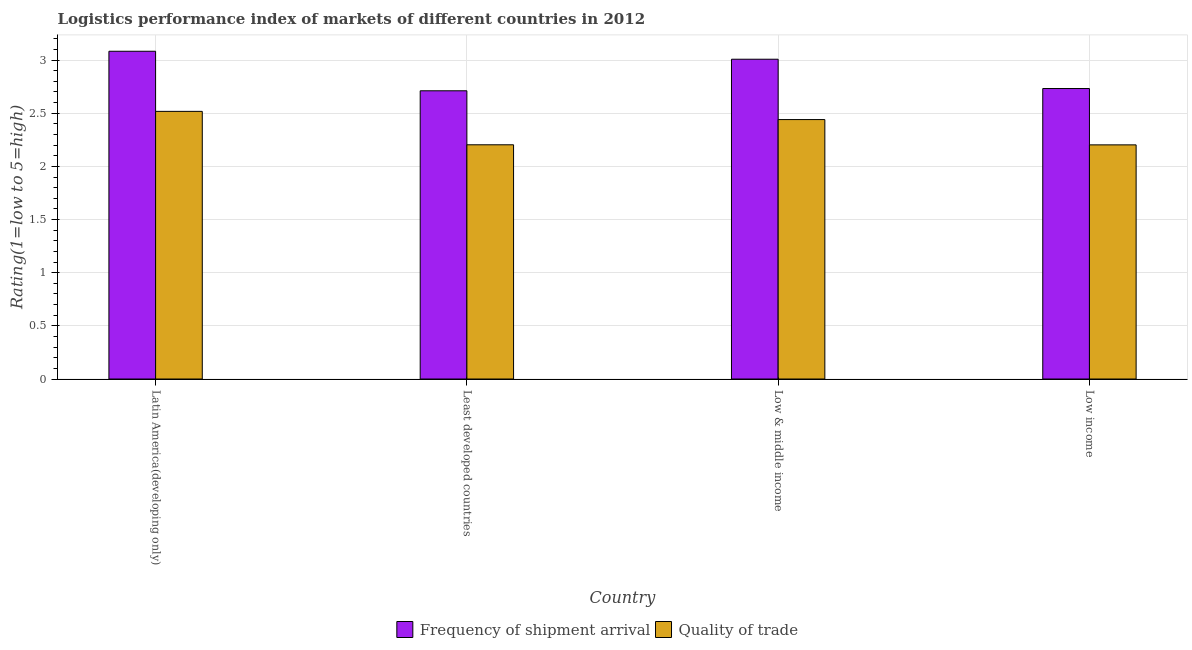How many different coloured bars are there?
Offer a terse response. 2. How many groups of bars are there?
Keep it short and to the point. 4. How many bars are there on the 4th tick from the right?
Keep it short and to the point. 2. What is the label of the 3rd group of bars from the left?
Ensure brevity in your answer.  Low & middle income. What is the lpi quality of trade in Latin America(developing only)?
Give a very brief answer. 2.52. Across all countries, what is the maximum lpi of frequency of shipment arrival?
Keep it short and to the point. 3.08. Across all countries, what is the minimum lpi quality of trade?
Ensure brevity in your answer.  2.2. In which country was the lpi quality of trade maximum?
Keep it short and to the point. Latin America(developing only). In which country was the lpi quality of trade minimum?
Offer a very short reply. Low income. What is the total lpi quality of trade in the graph?
Provide a short and direct response. 9.36. What is the difference between the lpi quality of trade in Least developed countries and that in Low income?
Offer a very short reply. 0. What is the difference between the lpi of frequency of shipment arrival in Low income and the lpi quality of trade in Low & middle income?
Provide a succinct answer. 0.29. What is the average lpi quality of trade per country?
Ensure brevity in your answer.  2.34. What is the difference between the lpi quality of trade and lpi of frequency of shipment arrival in Least developed countries?
Ensure brevity in your answer.  -0.51. In how many countries, is the lpi of frequency of shipment arrival greater than 2.9 ?
Ensure brevity in your answer.  2. What is the ratio of the lpi of frequency of shipment arrival in Least developed countries to that in Low income?
Offer a very short reply. 0.99. Is the lpi quality of trade in Latin America(developing only) less than that in Low & middle income?
Keep it short and to the point. No. Is the difference between the lpi of frequency of shipment arrival in Latin America(developing only) and Low income greater than the difference between the lpi quality of trade in Latin America(developing only) and Low income?
Provide a short and direct response. Yes. What is the difference between the highest and the second highest lpi quality of trade?
Provide a short and direct response. 0.08. What is the difference between the highest and the lowest lpi of frequency of shipment arrival?
Give a very brief answer. 0.37. What does the 1st bar from the left in Least developed countries represents?
Keep it short and to the point. Frequency of shipment arrival. What does the 1st bar from the right in Latin America(developing only) represents?
Provide a short and direct response. Quality of trade. How many bars are there?
Offer a terse response. 8. Are all the bars in the graph horizontal?
Your answer should be very brief. No. What is the difference between two consecutive major ticks on the Y-axis?
Provide a succinct answer. 0.5. Does the graph contain any zero values?
Your response must be concise. No. Does the graph contain grids?
Your answer should be very brief. Yes. How many legend labels are there?
Offer a very short reply. 2. How are the legend labels stacked?
Keep it short and to the point. Horizontal. What is the title of the graph?
Provide a short and direct response. Logistics performance index of markets of different countries in 2012. Does "Electricity" appear as one of the legend labels in the graph?
Provide a short and direct response. No. What is the label or title of the Y-axis?
Offer a very short reply. Rating(1=low to 5=high). What is the Rating(1=low to 5=high) in Frequency of shipment arrival in Latin America(developing only)?
Offer a very short reply. 3.08. What is the Rating(1=low to 5=high) of Quality of trade in Latin America(developing only)?
Your answer should be compact. 2.52. What is the Rating(1=low to 5=high) of Frequency of shipment arrival in Least developed countries?
Ensure brevity in your answer.  2.71. What is the Rating(1=low to 5=high) in Quality of trade in Least developed countries?
Provide a succinct answer. 2.2. What is the Rating(1=low to 5=high) in Frequency of shipment arrival in Low & middle income?
Your answer should be very brief. 3.01. What is the Rating(1=low to 5=high) in Quality of trade in Low & middle income?
Provide a short and direct response. 2.44. What is the Rating(1=low to 5=high) in Frequency of shipment arrival in Low income?
Give a very brief answer. 2.73. What is the Rating(1=low to 5=high) in Quality of trade in Low income?
Make the answer very short. 2.2. Across all countries, what is the maximum Rating(1=low to 5=high) of Frequency of shipment arrival?
Your answer should be compact. 3.08. Across all countries, what is the maximum Rating(1=low to 5=high) of Quality of trade?
Provide a succinct answer. 2.52. Across all countries, what is the minimum Rating(1=low to 5=high) of Frequency of shipment arrival?
Make the answer very short. 2.71. Across all countries, what is the minimum Rating(1=low to 5=high) in Quality of trade?
Make the answer very short. 2.2. What is the total Rating(1=low to 5=high) in Frequency of shipment arrival in the graph?
Provide a succinct answer. 11.53. What is the total Rating(1=low to 5=high) in Quality of trade in the graph?
Ensure brevity in your answer.  9.36. What is the difference between the Rating(1=low to 5=high) of Frequency of shipment arrival in Latin America(developing only) and that in Least developed countries?
Your answer should be compact. 0.37. What is the difference between the Rating(1=low to 5=high) in Quality of trade in Latin America(developing only) and that in Least developed countries?
Give a very brief answer. 0.31. What is the difference between the Rating(1=low to 5=high) in Frequency of shipment arrival in Latin America(developing only) and that in Low & middle income?
Give a very brief answer. 0.07. What is the difference between the Rating(1=low to 5=high) of Quality of trade in Latin America(developing only) and that in Low & middle income?
Offer a terse response. 0.08. What is the difference between the Rating(1=low to 5=high) in Frequency of shipment arrival in Latin America(developing only) and that in Low income?
Provide a short and direct response. 0.35. What is the difference between the Rating(1=low to 5=high) in Quality of trade in Latin America(developing only) and that in Low income?
Your answer should be very brief. 0.32. What is the difference between the Rating(1=low to 5=high) in Frequency of shipment arrival in Least developed countries and that in Low & middle income?
Keep it short and to the point. -0.3. What is the difference between the Rating(1=low to 5=high) of Quality of trade in Least developed countries and that in Low & middle income?
Provide a succinct answer. -0.24. What is the difference between the Rating(1=low to 5=high) in Frequency of shipment arrival in Least developed countries and that in Low income?
Offer a very short reply. -0.02. What is the difference between the Rating(1=low to 5=high) in Quality of trade in Least developed countries and that in Low income?
Your answer should be very brief. 0. What is the difference between the Rating(1=low to 5=high) in Frequency of shipment arrival in Low & middle income and that in Low income?
Keep it short and to the point. 0.28. What is the difference between the Rating(1=low to 5=high) of Quality of trade in Low & middle income and that in Low income?
Provide a succinct answer. 0.24. What is the difference between the Rating(1=low to 5=high) of Frequency of shipment arrival in Latin America(developing only) and the Rating(1=low to 5=high) of Quality of trade in Least developed countries?
Offer a terse response. 0.88. What is the difference between the Rating(1=low to 5=high) in Frequency of shipment arrival in Latin America(developing only) and the Rating(1=low to 5=high) in Quality of trade in Low & middle income?
Provide a short and direct response. 0.64. What is the difference between the Rating(1=low to 5=high) of Frequency of shipment arrival in Latin America(developing only) and the Rating(1=low to 5=high) of Quality of trade in Low income?
Your answer should be very brief. 0.88. What is the difference between the Rating(1=low to 5=high) of Frequency of shipment arrival in Least developed countries and the Rating(1=low to 5=high) of Quality of trade in Low & middle income?
Your answer should be compact. 0.27. What is the difference between the Rating(1=low to 5=high) of Frequency of shipment arrival in Least developed countries and the Rating(1=low to 5=high) of Quality of trade in Low income?
Provide a succinct answer. 0.51. What is the difference between the Rating(1=low to 5=high) of Frequency of shipment arrival in Low & middle income and the Rating(1=low to 5=high) of Quality of trade in Low income?
Ensure brevity in your answer.  0.81. What is the average Rating(1=low to 5=high) of Frequency of shipment arrival per country?
Offer a terse response. 2.88. What is the average Rating(1=low to 5=high) in Quality of trade per country?
Offer a terse response. 2.34. What is the difference between the Rating(1=low to 5=high) in Frequency of shipment arrival and Rating(1=low to 5=high) in Quality of trade in Latin America(developing only)?
Give a very brief answer. 0.57. What is the difference between the Rating(1=low to 5=high) of Frequency of shipment arrival and Rating(1=low to 5=high) of Quality of trade in Least developed countries?
Your response must be concise. 0.51. What is the difference between the Rating(1=low to 5=high) in Frequency of shipment arrival and Rating(1=low to 5=high) in Quality of trade in Low & middle income?
Ensure brevity in your answer.  0.57. What is the difference between the Rating(1=low to 5=high) of Frequency of shipment arrival and Rating(1=low to 5=high) of Quality of trade in Low income?
Your answer should be compact. 0.53. What is the ratio of the Rating(1=low to 5=high) in Frequency of shipment arrival in Latin America(developing only) to that in Least developed countries?
Give a very brief answer. 1.14. What is the ratio of the Rating(1=low to 5=high) in Quality of trade in Latin America(developing only) to that in Least developed countries?
Keep it short and to the point. 1.14. What is the ratio of the Rating(1=low to 5=high) of Frequency of shipment arrival in Latin America(developing only) to that in Low & middle income?
Your response must be concise. 1.02. What is the ratio of the Rating(1=low to 5=high) in Quality of trade in Latin America(developing only) to that in Low & middle income?
Ensure brevity in your answer.  1.03. What is the ratio of the Rating(1=low to 5=high) of Frequency of shipment arrival in Latin America(developing only) to that in Low income?
Give a very brief answer. 1.13. What is the ratio of the Rating(1=low to 5=high) of Quality of trade in Latin America(developing only) to that in Low income?
Offer a terse response. 1.14. What is the ratio of the Rating(1=low to 5=high) of Frequency of shipment arrival in Least developed countries to that in Low & middle income?
Your answer should be compact. 0.9. What is the ratio of the Rating(1=low to 5=high) in Quality of trade in Least developed countries to that in Low & middle income?
Your answer should be compact. 0.9. What is the ratio of the Rating(1=low to 5=high) of Quality of trade in Least developed countries to that in Low income?
Provide a short and direct response. 1. What is the ratio of the Rating(1=low to 5=high) in Frequency of shipment arrival in Low & middle income to that in Low income?
Your answer should be compact. 1.1. What is the ratio of the Rating(1=low to 5=high) in Quality of trade in Low & middle income to that in Low income?
Your answer should be very brief. 1.11. What is the difference between the highest and the second highest Rating(1=low to 5=high) in Frequency of shipment arrival?
Your answer should be very brief. 0.07. What is the difference between the highest and the second highest Rating(1=low to 5=high) in Quality of trade?
Offer a terse response. 0.08. What is the difference between the highest and the lowest Rating(1=low to 5=high) in Frequency of shipment arrival?
Your response must be concise. 0.37. What is the difference between the highest and the lowest Rating(1=low to 5=high) in Quality of trade?
Your response must be concise. 0.32. 